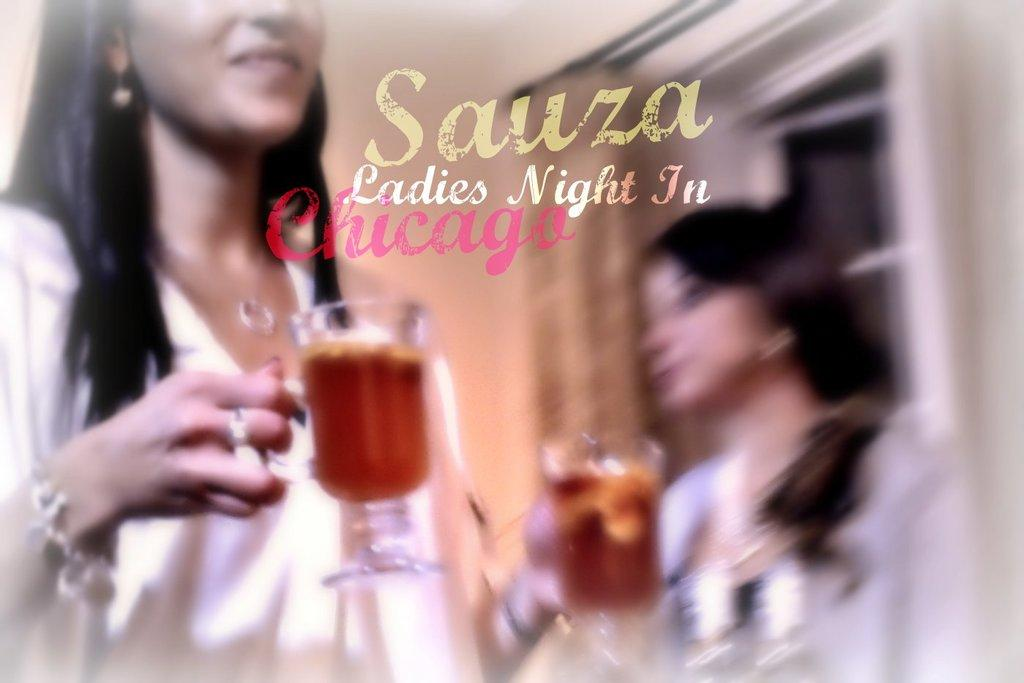How many women are in the image? There are two women in the image. What are the women doing in the image? The women are standing and holding wine glasses. What can be seen in the background of the image? There is a wall, a window, and a curtain associated with the window in the background of the image. What book is the woman reading in the image? There is no book present in the image; the women are holding wine glasses. What type of friction is being generated by the women's shoes in the image? There is no information about the women's shoes or any friction being generated in the image. 